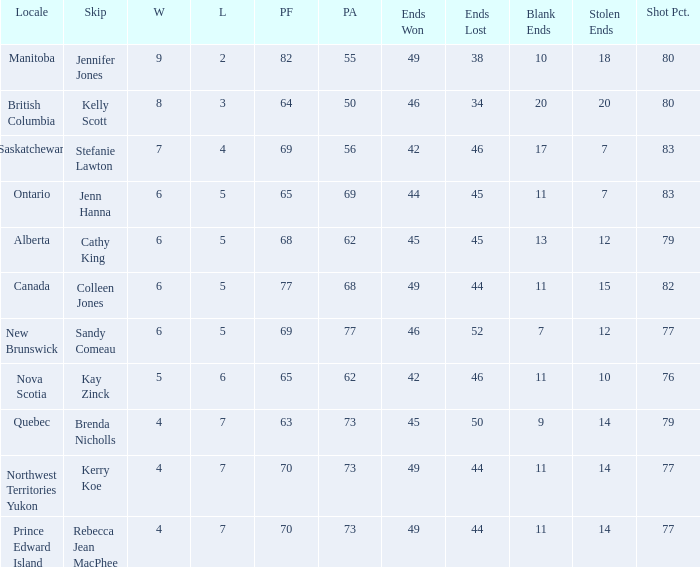What is the PA when the PF is 77? 68.0. Help me parse the entirety of this table. {'header': ['Locale', 'Skip', 'W', 'L', 'PF', 'PA', 'Ends Won', 'Ends Lost', 'Blank Ends', 'Stolen Ends', 'Shot Pct.'], 'rows': [['Manitoba', 'Jennifer Jones', '9', '2', '82', '55', '49', '38', '10', '18', '80'], ['British Columbia', 'Kelly Scott', '8', '3', '64', '50', '46', '34', '20', '20', '80'], ['Saskatchewan', 'Stefanie Lawton', '7', '4', '69', '56', '42', '46', '17', '7', '83'], ['Ontario', 'Jenn Hanna', '6', '5', '65', '69', '44', '45', '11', '7', '83'], ['Alberta', 'Cathy King', '6', '5', '68', '62', '45', '45', '13', '12', '79'], ['Canada', 'Colleen Jones', '6', '5', '77', '68', '49', '44', '11', '15', '82'], ['New Brunswick', 'Sandy Comeau', '6', '5', '69', '77', '46', '52', '7', '12', '77'], ['Nova Scotia', 'Kay Zinck', '5', '6', '65', '62', '42', '46', '11', '10', '76'], ['Quebec', 'Brenda Nicholls', '4', '7', '63', '73', '45', '50', '9', '14', '79'], ['Northwest Territories Yukon', 'Kerry Koe', '4', '7', '70', '73', '49', '44', '11', '14', '77'], ['Prince Edward Island', 'Rebecca Jean MacPhee', '4', '7', '70', '73', '49', '44', '11', '14', '77']]} 